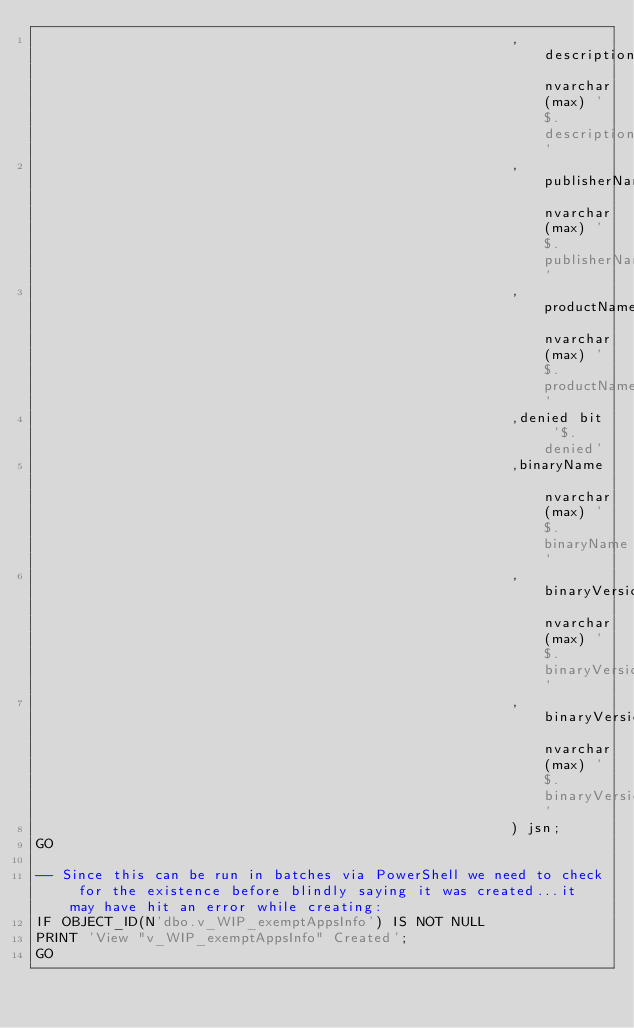<code> <loc_0><loc_0><loc_500><loc_500><_SQL_>                                                        ,description nvarchar(max) '$.description'
                                                        ,publisherName nvarchar(max) '$.publisherName'
                                                        ,productName nvarchar(max) '$.productName'
                                                        ,denied bit '$.denied'
                                                        ,binaryName nvarchar(max) '$.binaryName'
                                                        ,binaryVersionLow nvarchar(max) '$.binaryVersionLow'
                                                        ,binaryVersionHigh nvarchar(max) '$.binaryVersionHigh'
                                                        ) jsn;
GO

-- Since this can be run in batches via PowerShell we need to check for the existence before blindly saying it was created...it may have hit an error while creating:
IF OBJECT_ID(N'dbo.v_WIP_exemptAppsInfo') IS NOT NULL
PRINT 'View "v_WIP_exemptAppsInfo" Created';
GO</code> 